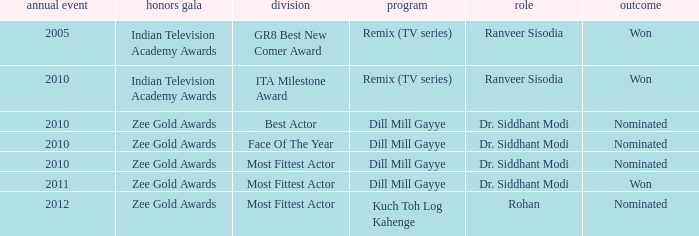Which character was nominated in the 2010 Indian Television Academy Awards? Ranveer Sisodia. 